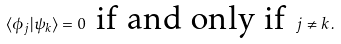<formula> <loc_0><loc_0><loc_500><loc_500>\langle \phi _ { j } | \psi _ { k } \rangle = 0 \, \text { if and only if } \, j \neq k \, .</formula> 